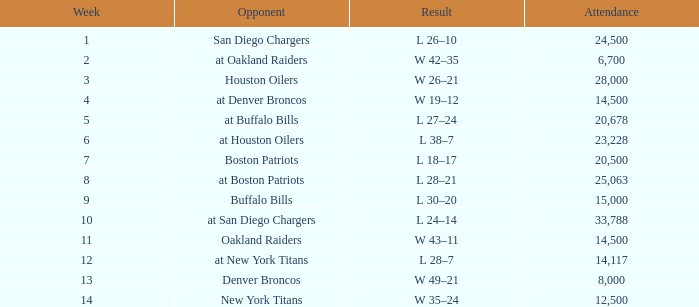What is the peak attendance for weeks following 2 on october 29, 1961? 20500.0. 